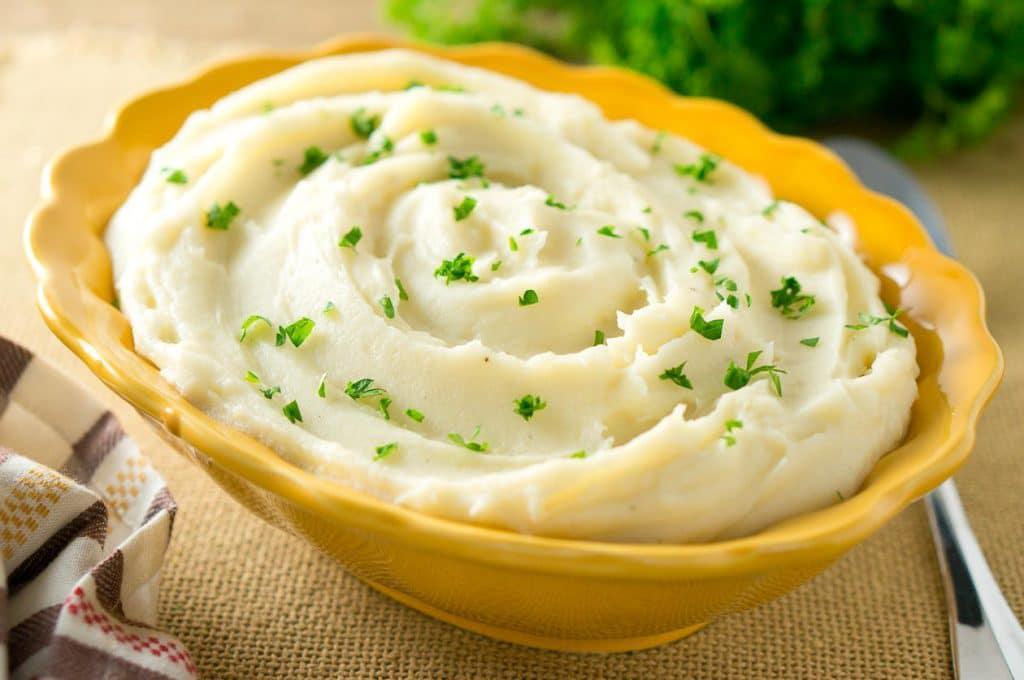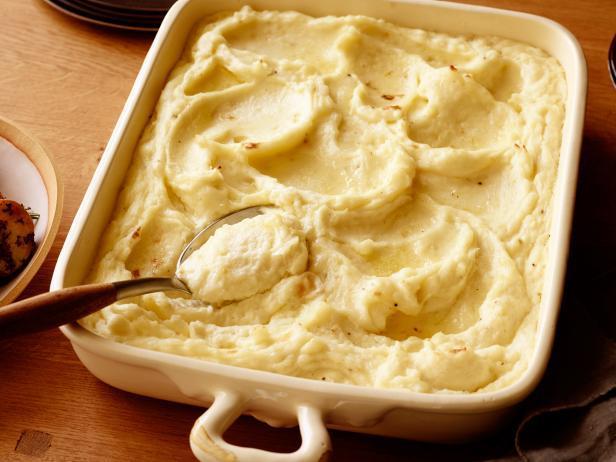The first image is the image on the left, the second image is the image on the right. Assess this claim about the two images: "A spoon sits in a bowl of potatoes in one of the images.". Correct or not? Answer yes or no. Yes. The first image is the image on the left, the second image is the image on the right. Analyze the images presented: Is the assertion "One image features a bowl of potatoes with a spoon in the food." valid? Answer yes or no. Yes. 